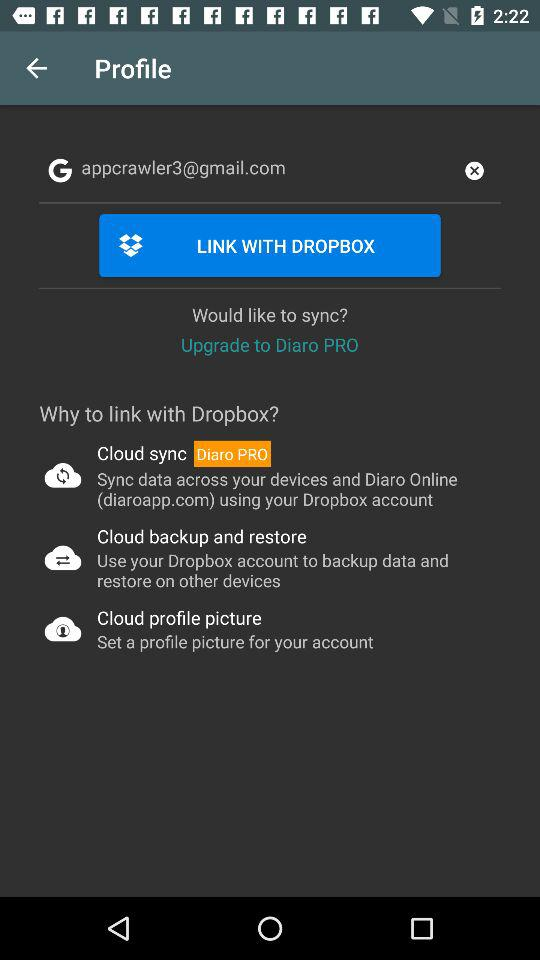How much does the upgrade cost?
When the provided information is insufficient, respond with <no answer>. <no answer> 